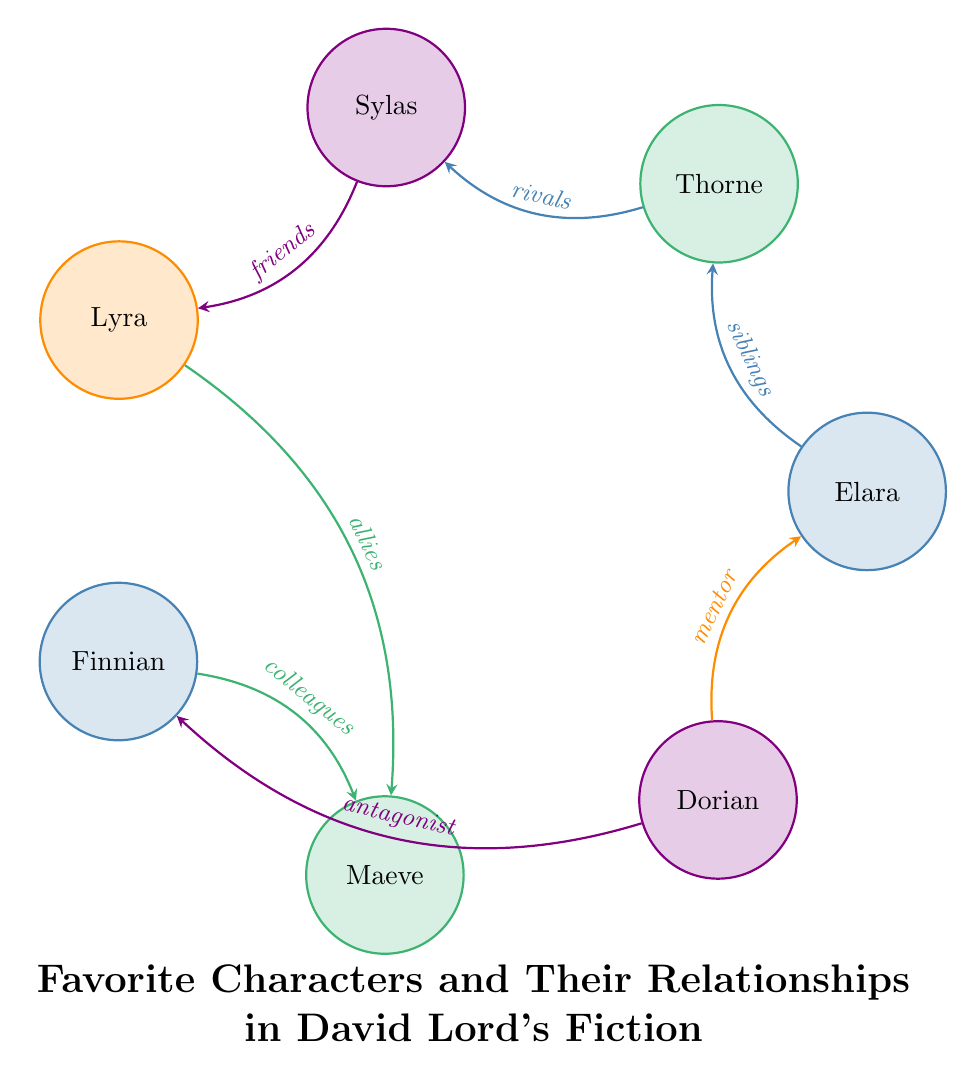What is the relationship between Elara and Thorne? In the diagram, there is a directed edge labeled "siblings" that connects Elara and Thorne, indicating their relationship.
Answer: siblings How many characters are represented in the diagram? The diagram includes a total of 7 characters represented as nodes, which are Elara, Thorne, Sylas, Lyra, Finnian, Maeve, and Dorian.
Answer: 7 Who is Dorian's antagonist? By observing the diagram, there is an arrow originating from Dorian and pointing to Finnian, with the label "antagonist," indicating that Dorian is the antagonist of Finnian.
Answer: Finnian What type of relationship do Sylas and Lyra have? Looking at the connection between Sylas and Lyra in the diagram, it is labeled as "friends," which describes the nature of their relationship.
Answer: friends Which character is both a mentor and has a rival in the diagram? Dorian is the mentor to Elara and has a rival relationship with Finnian, which shows that he plays diverse roles. Thus, he is the character who fits this description.
Answer: Dorian How many relationships involve Maeve? Maeve is involved in two relationships according to the diagram: one with Finnian as colleagues and another with Lyra as allies. Therefore, the count of her relationships is two.
Answer: 2 Who are the allies in the diagram? The connection that represents allies in the diagram is between Lyra and Maeve, which is indicated by the respective arrow labeled "allies."
Answer: Lyra and Maeve Which character has the most outgoing connections in terms of relationships? By examining the outgoing arrows, Dorian has two outgoing connections (to Elara as mentor and to Finnian as antagonist), making him the character with the most outgoing relationships.
Answer: Dorian 